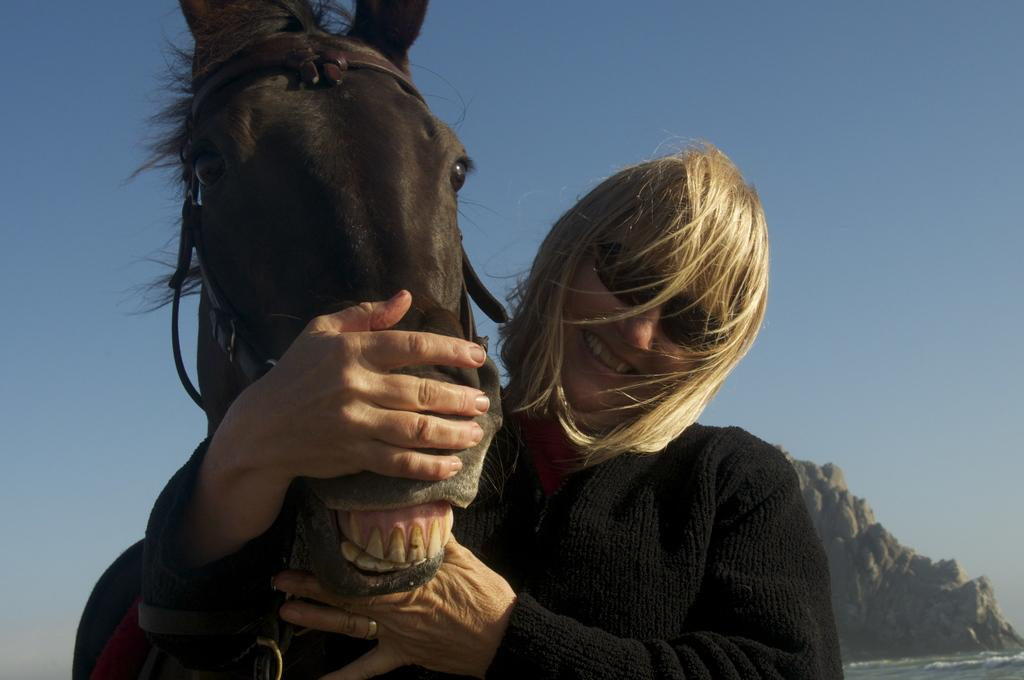Who is the main subject in the image? There is a woman in the image. What is the woman wearing on her face? The woman is wearing glasses. What type of clothing is the woman wearing? The woman is wearing a black jacket. What is the woman holding in the image? The woman is holding a horse. What can be seen in the background of the image? There is water, a mountain, and the sky visible in the background of the image. What type of honey is the woman feeding to her brother in the image? There is no honey or brother present in the image; it features a woman holding a horse. What type of ground can be seen in the image? The ground is not explicitly visible in the image, but it can be inferred that there is ground beneath the water and the woman holding the horse. 